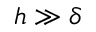Convert formula to latex. <formula><loc_0><loc_0><loc_500><loc_500>h \gg \delta</formula> 